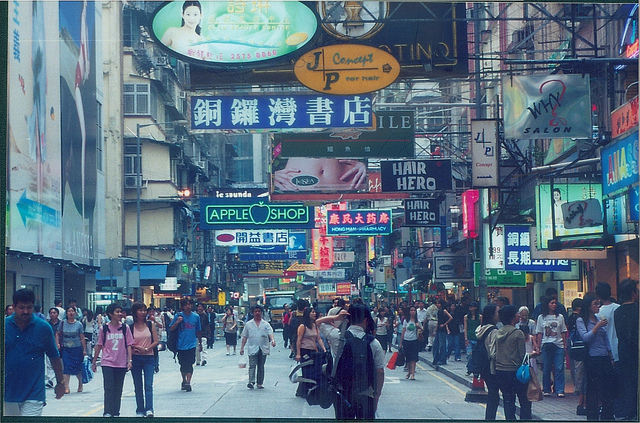<image>What brand of watch is being advertised? It is ambiguous about the brand of watch that is being advertised. The possible answers could be 'Apple' or 'Timex', or there may not be a watch at all in the advertisement. What brand of watch is being advertised? I am not sure what brand of watch is being advertised. It can be seen as 'apple', 'timex' or 'none'. 